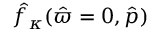Convert formula to latex. <formula><loc_0><loc_0><loc_500><loc_500>\hat { f } _ { \kappa } ( \hat { \varpi } = 0 , \hat { p } )</formula> 